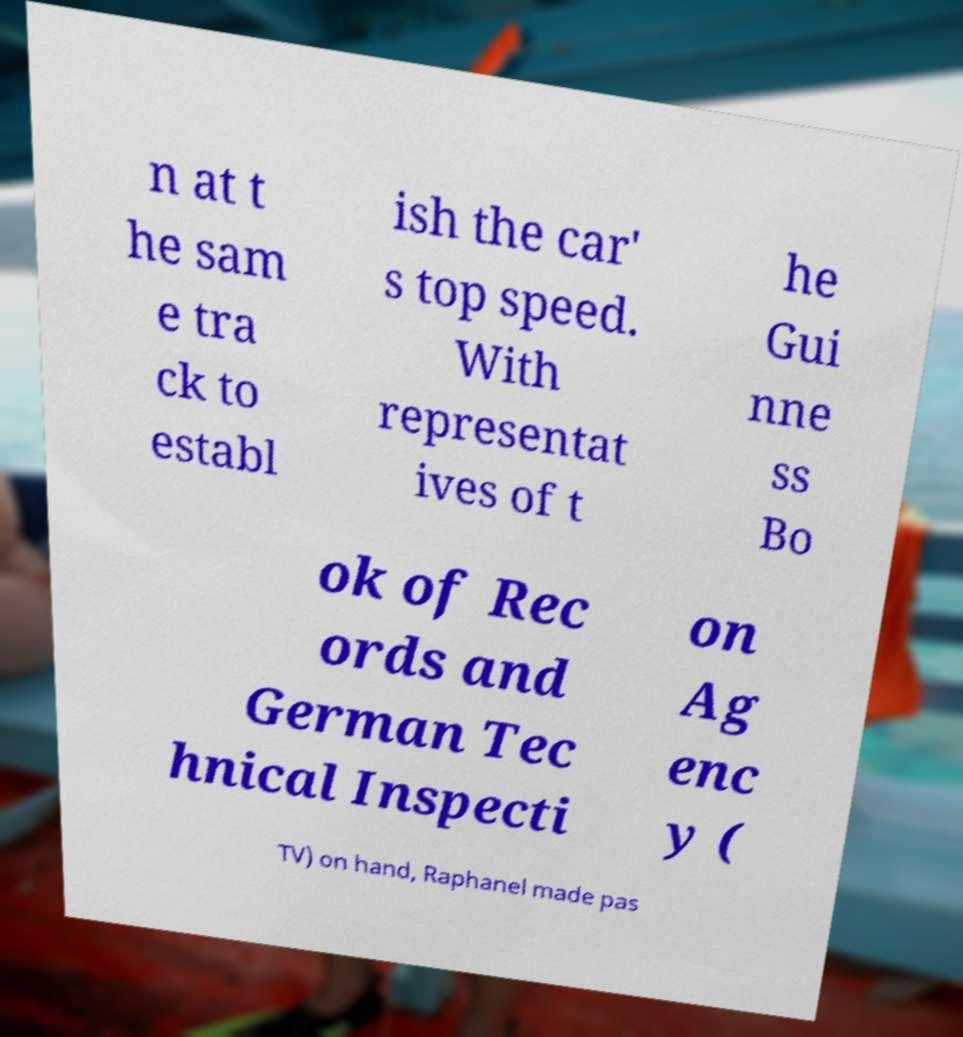Please identify and transcribe the text found in this image. n at t he sam e tra ck to establ ish the car' s top speed. With representat ives of t he Gui nne ss Bo ok of Rec ords and German Tec hnical Inspecti on Ag enc y ( TV) on hand, Raphanel made pas 